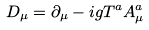Convert formula to latex. <formula><loc_0><loc_0><loc_500><loc_500>D _ { \mu } = \partial _ { \mu } - i g T ^ { a } A _ { \mu } ^ { a }</formula> 